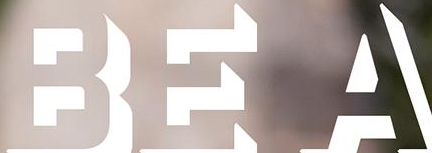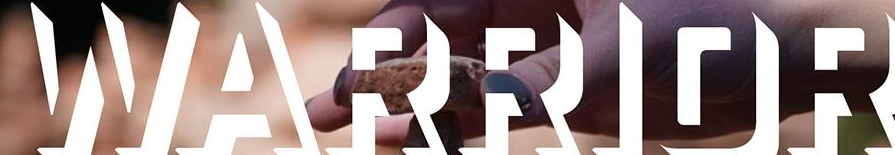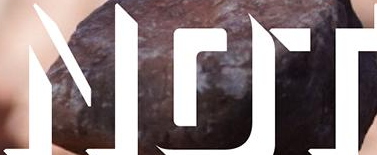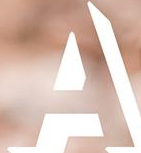Identify the words shown in these images in order, separated by a semicolon. BEA; WARRIOR; NOT; A 